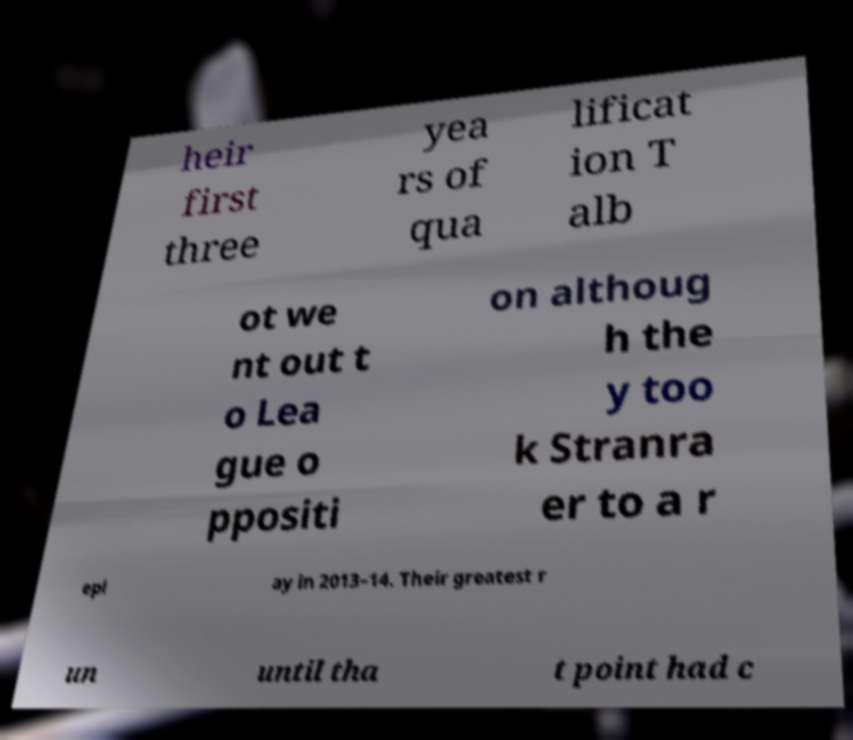Could you assist in decoding the text presented in this image and type it out clearly? heir first three yea rs of qua lificat ion T alb ot we nt out t o Lea gue o ppositi on althoug h the y too k Stranra er to a r epl ay in 2013–14. Their greatest r un until tha t point had c 